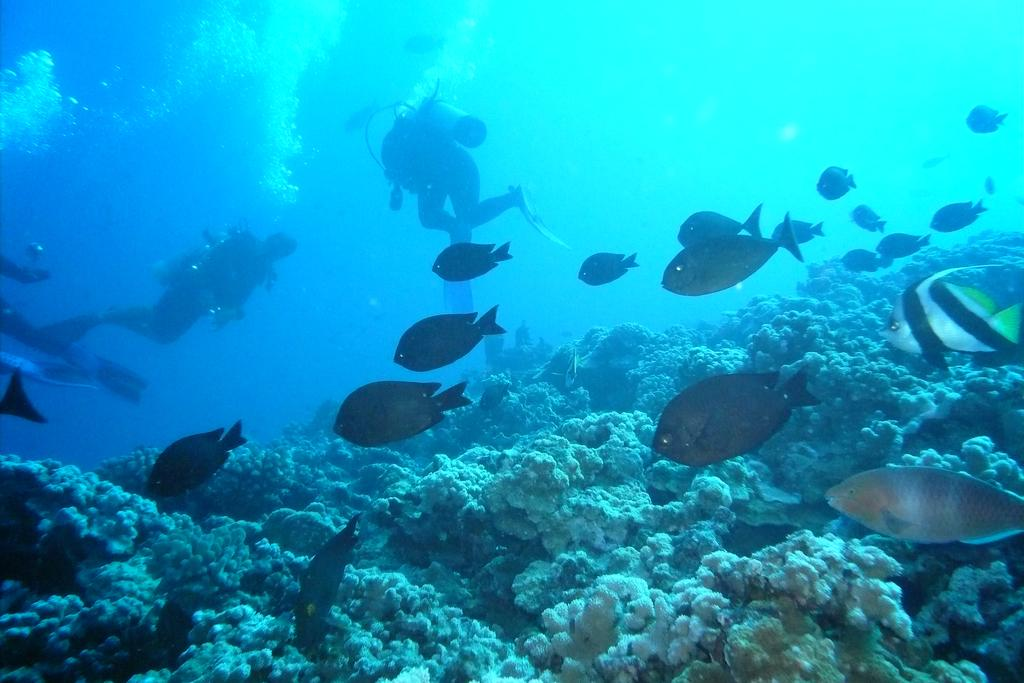How many people are in the image? There are three persons in the image. Where are the persons located in the image? The persons are underwater in the image. What other living creatures can be seen in the image? There are fishes in the image. What else is present in front of the persons? There are other objects in front of the persons. What is the condition of the base in the image? There is no base present in the image; it is set underwater with the persons and fishes. How can the increase in oxygen levels be observed in the image? The image does not provide information about oxygen levels or any changes in them. 